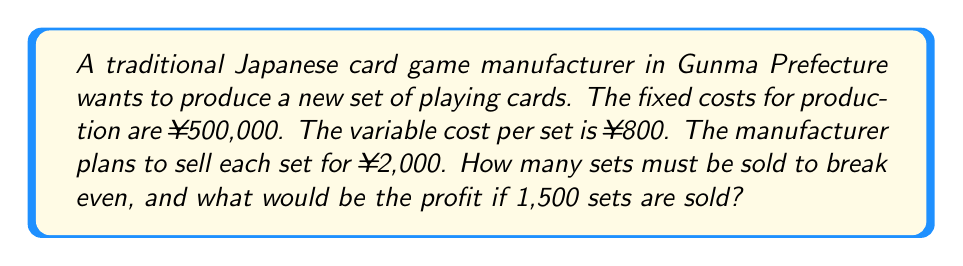Teach me how to tackle this problem. Let's approach this problem step-by-step:

1) First, let's define our variables:
   $x$ = number of sets sold
   $P$ = profit

2) We can express the total revenue as:
   Revenue = Price per set × Number of sets
   $R = 2000x$

3) The total cost is the sum of fixed costs and variable costs:
   Total Cost = Fixed Cost + (Variable Cost per set × Number of sets)
   $C = 500000 + 800x$

4) Profit is the difference between revenue and cost:
   $P = R - C = 2000x - (500000 + 800x) = 1200x - 500000$

5) To find the break-even point, we set profit to zero:
   $0 = 1200x - 500000$
   $500000 = 1200x$
   $x = \frac{500000}{1200} = 416.67$

   Since we can't sell a fraction of a set, we round up to 417 sets.

6) To calculate the profit for 1,500 sets:
   $P = 1200(1500) - 500000 = 1800000 - 500000 = 1300000$

Therefore, the profit for selling 1,500 sets would be ¥1,300,000.
Answer: 417 sets to break even; ¥1,300,000 profit for 1,500 sets 